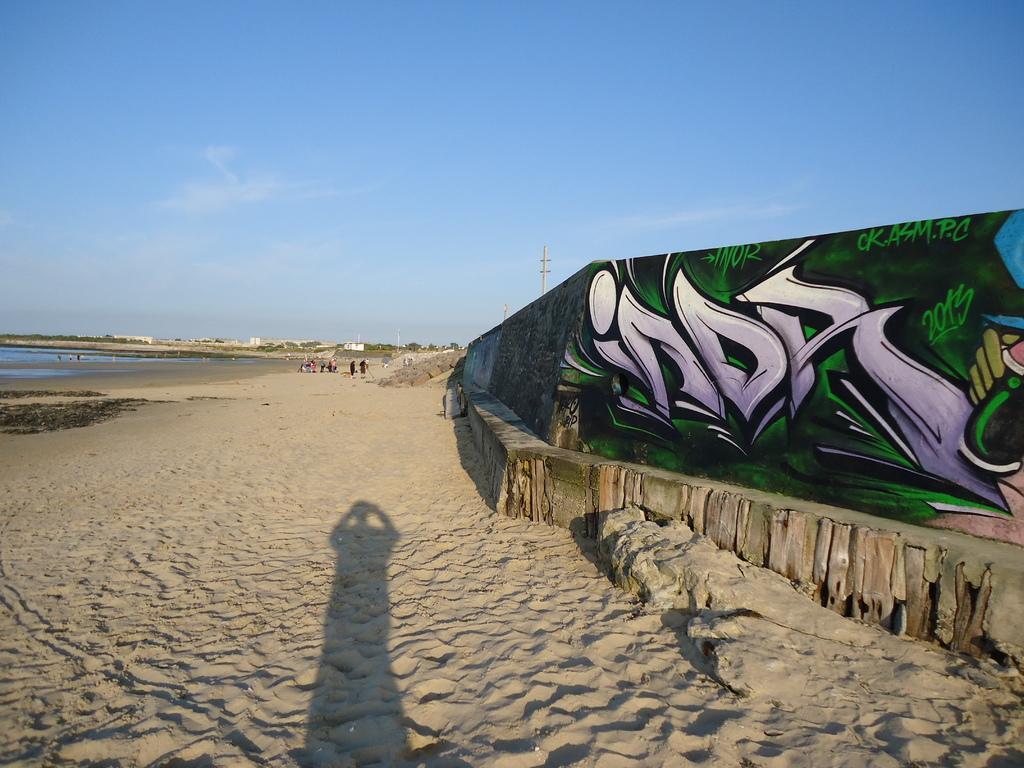Describe this image in one or two sentences. This image is clicked near the beach. At the bottom, there is sand. On the right, there is a wall on which there is a painting. On the left, we can see a water. At the top, there is sky. 